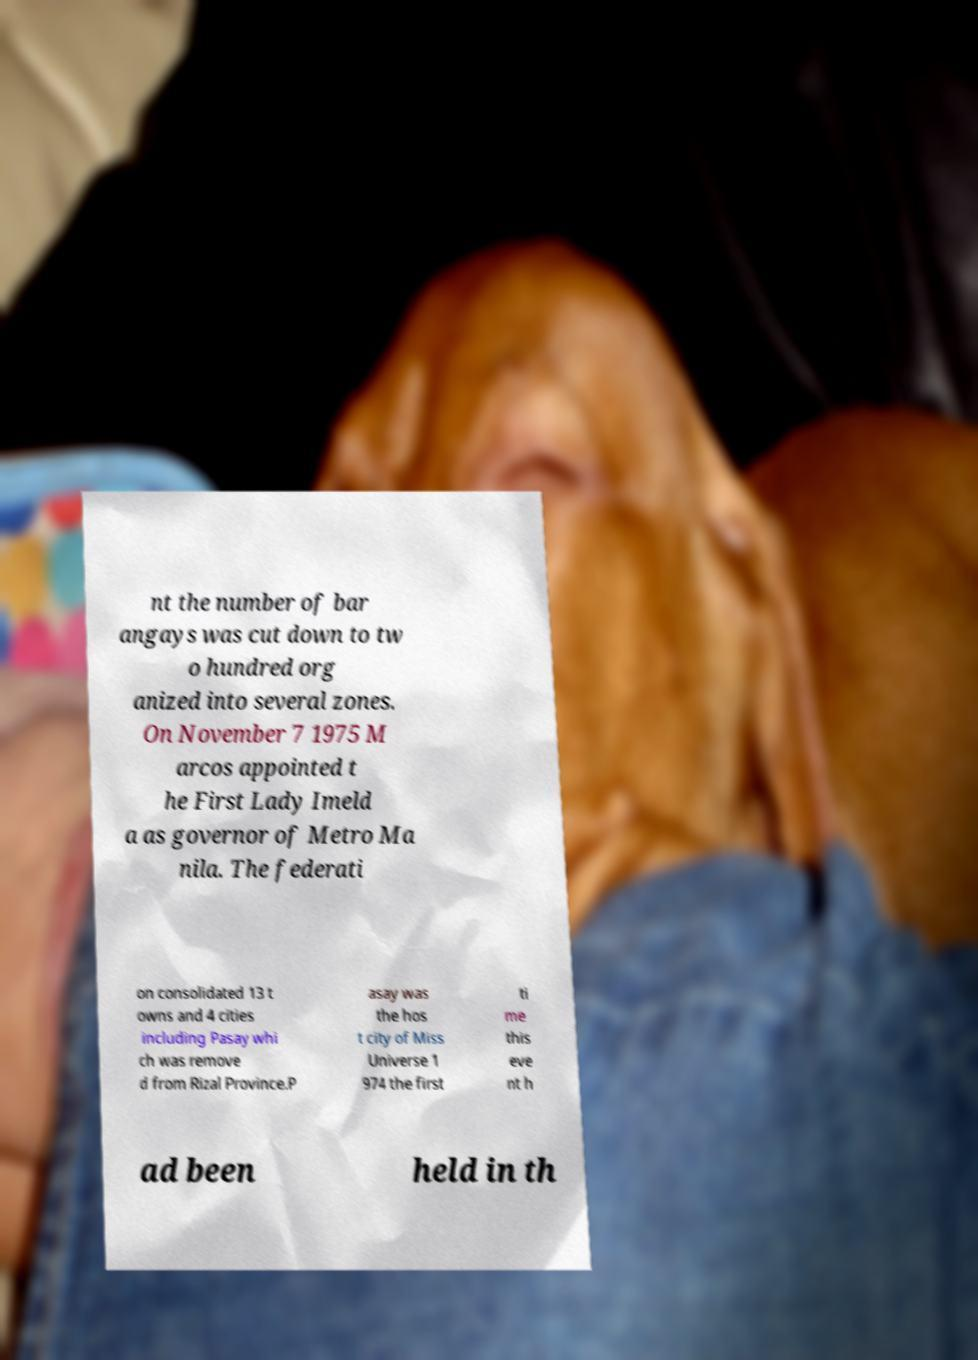What messages or text are displayed in this image? I need them in a readable, typed format. nt the number of bar angays was cut down to tw o hundred org anized into several zones. On November 7 1975 M arcos appointed t he First Lady Imeld a as governor of Metro Ma nila. The federati on consolidated 13 t owns and 4 cities including Pasay whi ch was remove d from Rizal Province.P asay was the hos t city of Miss Universe 1 974 the first ti me this eve nt h ad been held in th 